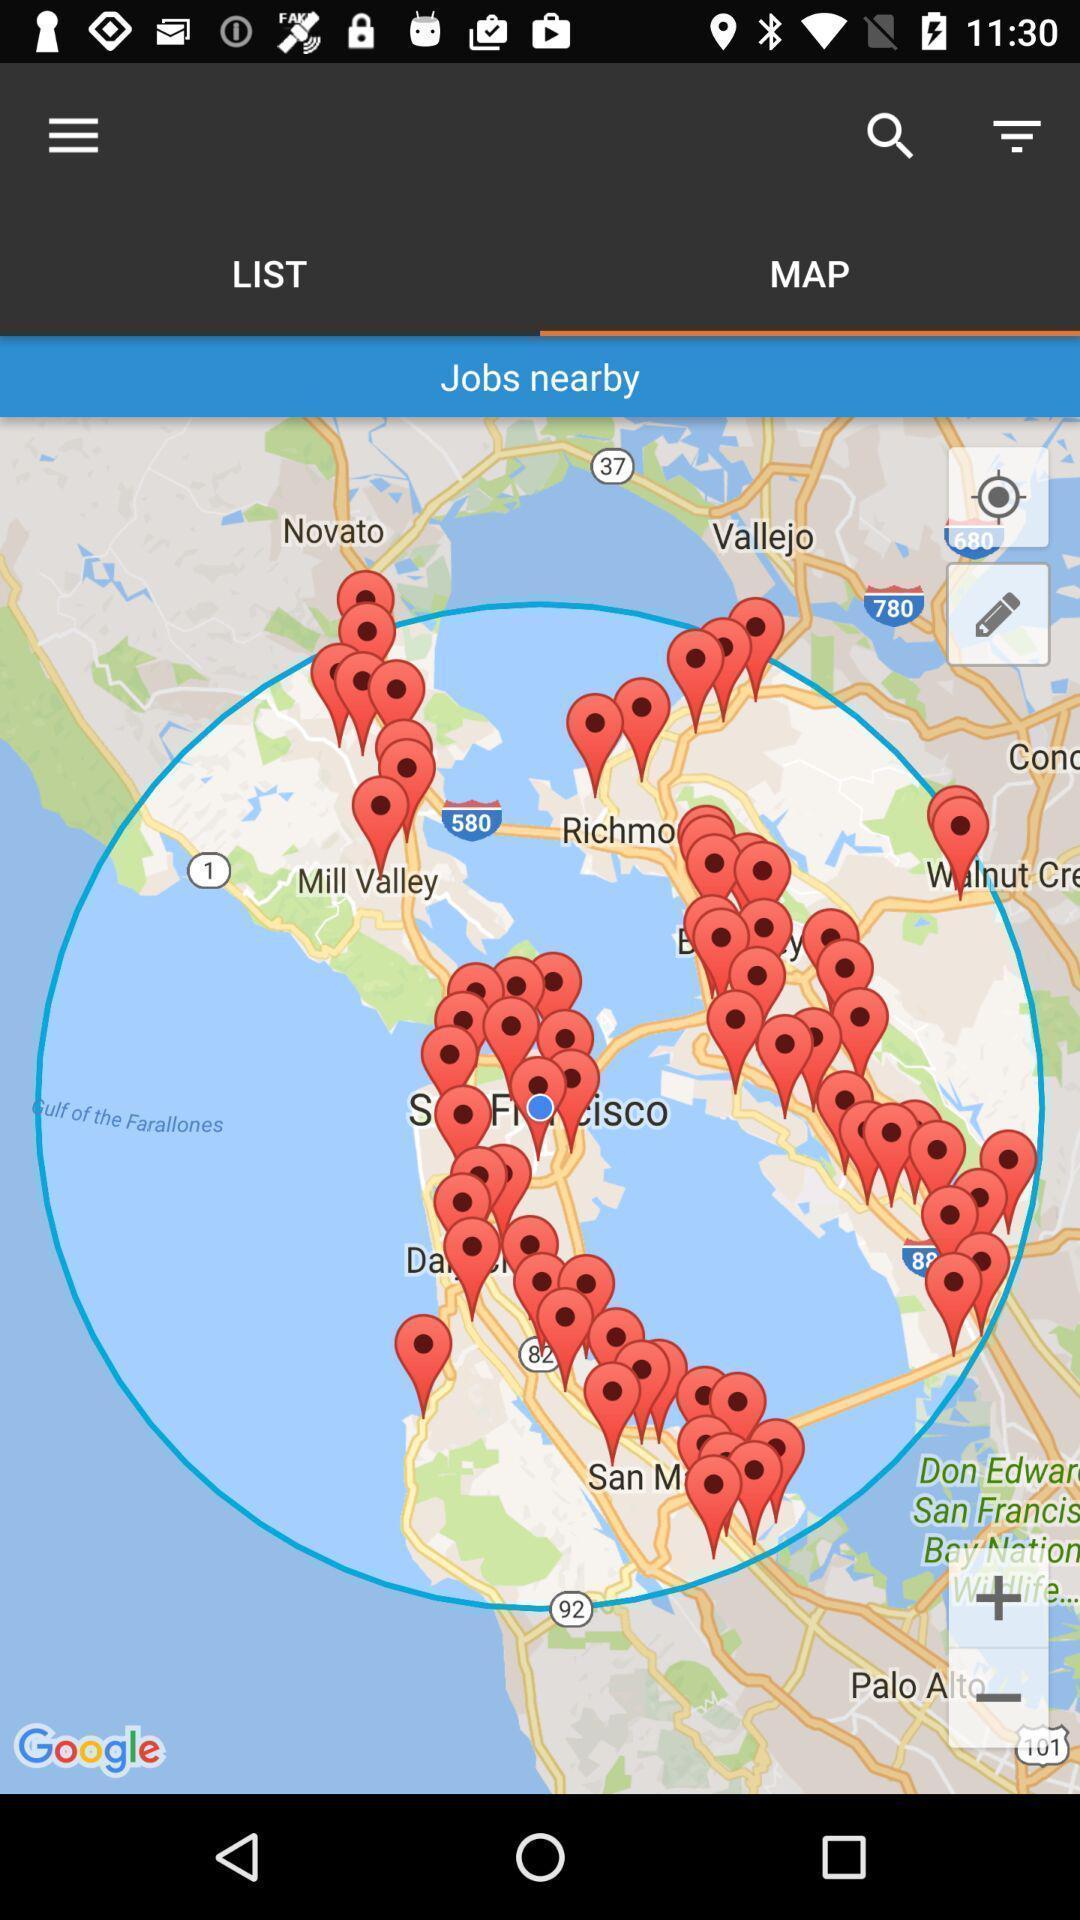Tell me about the visual elements in this screen capture. Screen shows map view in a career app. 